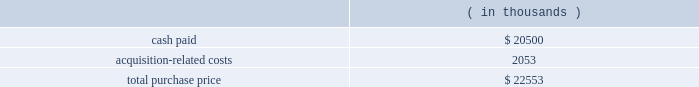Note 3 .
Business combinations purchase combinations .
During the fiscal years presented , the company made a number of purchase acquisitions .
For each acquisition , the excess of the purchase price over the estimated value of the net tangible assets acquired was allocated to various intangible assets , consisting primarily of developed technology , customer and contract-related assets and goodwill .
The values assigned to developed technologies related to each acquisition were based upon future discounted cash flows related to the existing products 2019 projected income streams .
Goodwill , representing the excess of the purchase consideration over the fair value of tangible and identifiable intangible assets acquired in the acquisitions , will not to be amortized .
Goodwill is not deductible for tax purposes .
The amounts allocated to purchased in-process research and developments were determined through established valuation techniques in the high-technology industry and were expensed upon acquisition because technological feasibility had not been established and no future alternative uses existed .
The consolidated financial statements include the operating results of each business from the date of acquisition .
The company does not consider these acquisitions to be material to its results of operations and is therefore not presenting pro forma statements of operations for the fiscal years ended october 31 , 2006 , 2005 and 2004 .
Fiscal 2006 acquisitions sigma-c software ag ( sigma-c ) the company acquired sigma-c on august 16 , 2006 in an all-cash transaction .
Reasons for the acquisition .
Sigma-c provides simulation software that allows semiconductor manufacturers and their suppliers to develop and optimize process sequences for optical lithography , e-beam lithography and next-generation lithography technologies .
The company believes the acquisition will enable a tighter integration between design and manufacturing tools , allowing the company 2019s customers to perform more accurate design layout analysis with 3d lithography simulation and better understand issues that affect ic wafer yields .
Purchase price .
The company paid $ 20.5 million in cash for the outstanding shares and shareholder notes of which $ 2.05 million was deposited with an escrow agent and will be paid per the escrow agreement .
The company believes that the escrow amount will be paid .
The total purchase consideration consisted of: .
Acquisition-related costs of $ 2.1 million consist primarily of legal , tax and accounting fees , estimated facilities closure costs and employee termination costs .
As of october 31 , 2006 , the company had paid $ 0.9 million of the acquisition-related costs .
The $ 1.2 million balance remaining at october 31 , 2006 primarily consists of legal , tax and accounting fees , estimated facilities closure costs and employee termination costs .
Assets acquired .
The company performed a preliminary valuation and allocated the total purchase consideration to assets and liabilities .
The company acquired $ 6.0 million of intangible assets consisting of $ 3.9 million in existing technology , $ 1.9 million in customer relationships and $ 0.2 million in trade names to be amortized over five years .
The company also acquired assets of $ 3.9 million and assumed liabilities of $ 5.1 million as result of this transaction .
Goodwill , representing the excess of the purchase price over the .
Customer relationships represented what percentage of the intangible assets? 
Computations: (1.9 / 6)
Answer: 0.31667. 